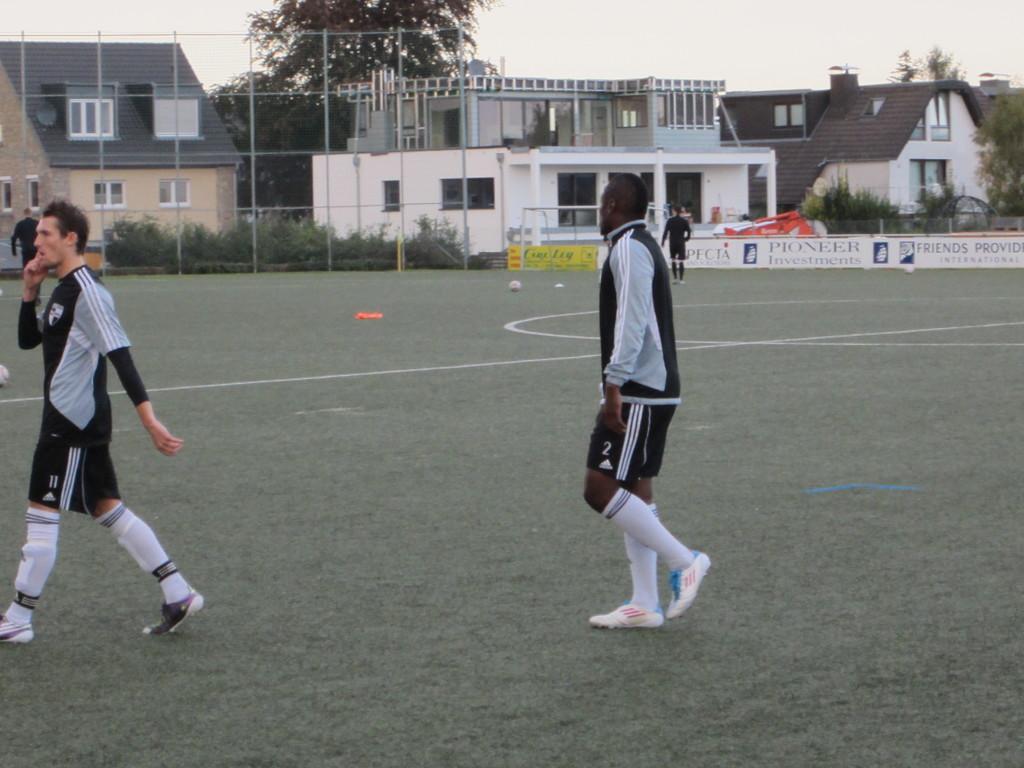Please provide a concise description of this image. In the image we can see there are many people walking, they are wearing clothes, socks and shoes. This is a grass, white lines, ball, buildings, windows of the building, poster, plants, fence, trees and a sky. 